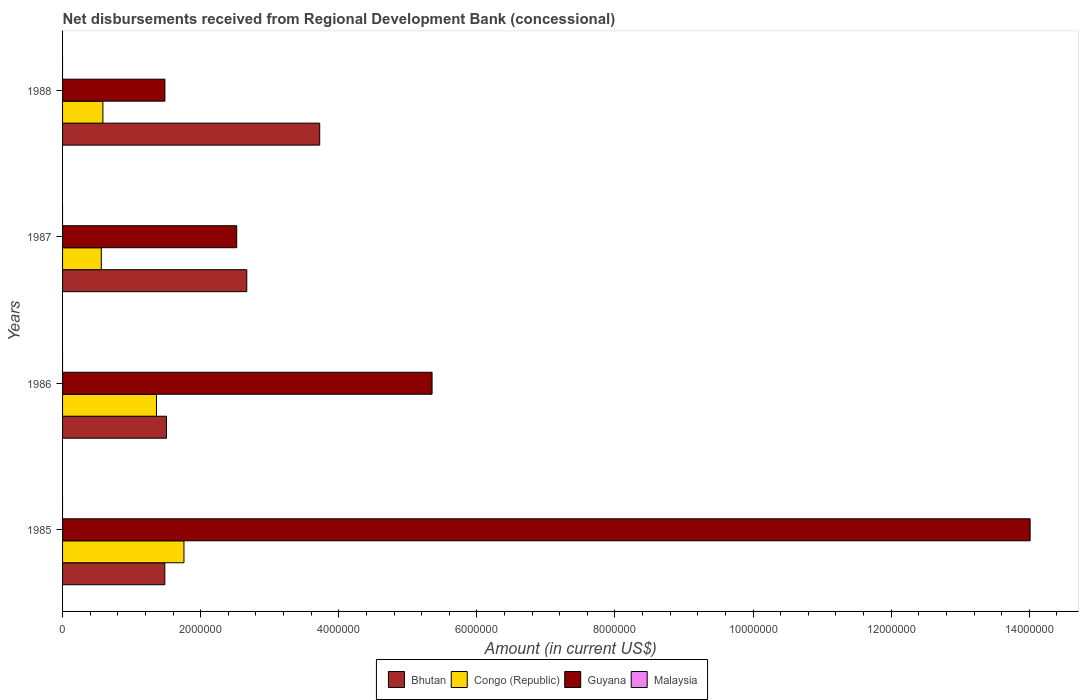How many groups of bars are there?
Offer a terse response. 4. Are the number of bars on each tick of the Y-axis equal?
Provide a succinct answer. Yes. How many bars are there on the 1st tick from the top?
Your answer should be compact. 3. How many bars are there on the 2nd tick from the bottom?
Your response must be concise. 3. Across all years, what is the maximum amount of disbursements received from Regional Development Bank in Guyana?
Offer a very short reply. 1.40e+07. Across all years, what is the minimum amount of disbursements received from Regional Development Bank in Congo (Republic)?
Provide a short and direct response. 5.61e+05. In which year was the amount of disbursements received from Regional Development Bank in Bhutan maximum?
Your response must be concise. 1988. What is the total amount of disbursements received from Regional Development Bank in Guyana in the graph?
Your response must be concise. 2.34e+07. What is the difference between the amount of disbursements received from Regional Development Bank in Congo (Republic) in 1985 and that in 1986?
Your answer should be very brief. 3.98e+05. What is the difference between the amount of disbursements received from Regional Development Bank in Bhutan in 1988 and the amount of disbursements received from Regional Development Bank in Guyana in 1985?
Provide a short and direct response. -1.03e+07. What is the average amount of disbursements received from Regional Development Bank in Guyana per year?
Offer a terse response. 5.84e+06. In the year 1986, what is the difference between the amount of disbursements received from Regional Development Bank in Congo (Republic) and amount of disbursements received from Regional Development Bank in Bhutan?
Offer a terse response. -1.45e+05. What is the ratio of the amount of disbursements received from Regional Development Bank in Bhutan in 1985 to that in 1986?
Provide a short and direct response. 0.98. Is the amount of disbursements received from Regional Development Bank in Guyana in 1985 less than that in 1987?
Provide a short and direct response. No. What is the difference between the highest and the second highest amount of disbursements received from Regional Development Bank in Guyana?
Keep it short and to the point. 8.66e+06. What is the difference between the highest and the lowest amount of disbursements received from Regional Development Bank in Bhutan?
Ensure brevity in your answer.  2.24e+06. Is the sum of the amount of disbursements received from Regional Development Bank in Guyana in 1985 and 1987 greater than the maximum amount of disbursements received from Regional Development Bank in Bhutan across all years?
Provide a short and direct response. Yes. Is it the case that in every year, the sum of the amount of disbursements received from Regional Development Bank in Malaysia and amount of disbursements received from Regional Development Bank in Bhutan is greater than the sum of amount of disbursements received from Regional Development Bank in Guyana and amount of disbursements received from Regional Development Bank in Congo (Republic)?
Your answer should be compact. No. How many bars are there?
Offer a terse response. 12. What is the difference between two consecutive major ticks on the X-axis?
Your answer should be compact. 2.00e+06. Does the graph contain grids?
Make the answer very short. No. Where does the legend appear in the graph?
Give a very brief answer. Bottom center. How many legend labels are there?
Your answer should be very brief. 4. What is the title of the graph?
Your response must be concise. Net disbursements received from Regional Development Bank (concessional). What is the label or title of the Y-axis?
Make the answer very short. Years. What is the Amount (in current US$) in Bhutan in 1985?
Provide a succinct answer. 1.48e+06. What is the Amount (in current US$) in Congo (Republic) in 1985?
Give a very brief answer. 1.76e+06. What is the Amount (in current US$) in Guyana in 1985?
Your answer should be compact. 1.40e+07. What is the Amount (in current US$) in Bhutan in 1986?
Offer a terse response. 1.50e+06. What is the Amount (in current US$) in Congo (Republic) in 1986?
Ensure brevity in your answer.  1.36e+06. What is the Amount (in current US$) in Guyana in 1986?
Make the answer very short. 5.35e+06. What is the Amount (in current US$) in Bhutan in 1987?
Provide a succinct answer. 2.67e+06. What is the Amount (in current US$) in Congo (Republic) in 1987?
Your answer should be very brief. 5.61e+05. What is the Amount (in current US$) in Guyana in 1987?
Provide a short and direct response. 2.52e+06. What is the Amount (in current US$) in Malaysia in 1987?
Provide a short and direct response. 0. What is the Amount (in current US$) of Bhutan in 1988?
Your answer should be very brief. 3.72e+06. What is the Amount (in current US$) of Congo (Republic) in 1988?
Provide a succinct answer. 5.84e+05. What is the Amount (in current US$) in Guyana in 1988?
Provide a short and direct response. 1.48e+06. What is the Amount (in current US$) of Malaysia in 1988?
Offer a terse response. 0. Across all years, what is the maximum Amount (in current US$) in Bhutan?
Provide a short and direct response. 3.72e+06. Across all years, what is the maximum Amount (in current US$) of Congo (Republic)?
Your answer should be very brief. 1.76e+06. Across all years, what is the maximum Amount (in current US$) in Guyana?
Provide a succinct answer. 1.40e+07. Across all years, what is the minimum Amount (in current US$) of Bhutan?
Make the answer very short. 1.48e+06. Across all years, what is the minimum Amount (in current US$) in Congo (Republic)?
Ensure brevity in your answer.  5.61e+05. Across all years, what is the minimum Amount (in current US$) of Guyana?
Offer a terse response. 1.48e+06. What is the total Amount (in current US$) in Bhutan in the graph?
Offer a very short reply. 9.38e+06. What is the total Amount (in current US$) in Congo (Republic) in the graph?
Your answer should be very brief. 4.26e+06. What is the total Amount (in current US$) in Guyana in the graph?
Your response must be concise. 2.34e+07. What is the total Amount (in current US$) of Malaysia in the graph?
Keep it short and to the point. 0. What is the difference between the Amount (in current US$) of Bhutan in 1985 and that in 1986?
Your answer should be very brief. -2.40e+04. What is the difference between the Amount (in current US$) of Congo (Republic) in 1985 and that in 1986?
Ensure brevity in your answer.  3.98e+05. What is the difference between the Amount (in current US$) of Guyana in 1985 and that in 1986?
Provide a short and direct response. 8.66e+06. What is the difference between the Amount (in current US$) of Bhutan in 1985 and that in 1987?
Keep it short and to the point. -1.19e+06. What is the difference between the Amount (in current US$) of Congo (Republic) in 1985 and that in 1987?
Offer a very short reply. 1.20e+06. What is the difference between the Amount (in current US$) in Guyana in 1985 and that in 1987?
Your response must be concise. 1.15e+07. What is the difference between the Amount (in current US$) of Bhutan in 1985 and that in 1988?
Offer a very short reply. -2.24e+06. What is the difference between the Amount (in current US$) in Congo (Republic) in 1985 and that in 1988?
Keep it short and to the point. 1.17e+06. What is the difference between the Amount (in current US$) in Guyana in 1985 and that in 1988?
Your answer should be very brief. 1.25e+07. What is the difference between the Amount (in current US$) of Bhutan in 1986 and that in 1987?
Your response must be concise. -1.16e+06. What is the difference between the Amount (in current US$) of Congo (Republic) in 1986 and that in 1987?
Offer a very short reply. 7.99e+05. What is the difference between the Amount (in current US$) of Guyana in 1986 and that in 1987?
Offer a terse response. 2.83e+06. What is the difference between the Amount (in current US$) in Bhutan in 1986 and that in 1988?
Your answer should be compact. -2.22e+06. What is the difference between the Amount (in current US$) in Congo (Republic) in 1986 and that in 1988?
Provide a succinct answer. 7.76e+05. What is the difference between the Amount (in current US$) in Guyana in 1986 and that in 1988?
Keep it short and to the point. 3.87e+06. What is the difference between the Amount (in current US$) in Bhutan in 1987 and that in 1988?
Your answer should be compact. -1.06e+06. What is the difference between the Amount (in current US$) in Congo (Republic) in 1987 and that in 1988?
Your answer should be very brief. -2.30e+04. What is the difference between the Amount (in current US$) of Guyana in 1987 and that in 1988?
Keep it short and to the point. 1.04e+06. What is the difference between the Amount (in current US$) of Bhutan in 1985 and the Amount (in current US$) of Congo (Republic) in 1986?
Provide a succinct answer. 1.21e+05. What is the difference between the Amount (in current US$) of Bhutan in 1985 and the Amount (in current US$) of Guyana in 1986?
Give a very brief answer. -3.87e+06. What is the difference between the Amount (in current US$) of Congo (Republic) in 1985 and the Amount (in current US$) of Guyana in 1986?
Your response must be concise. -3.59e+06. What is the difference between the Amount (in current US$) in Bhutan in 1985 and the Amount (in current US$) in Congo (Republic) in 1987?
Make the answer very short. 9.20e+05. What is the difference between the Amount (in current US$) in Bhutan in 1985 and the Amount (in current US$) in Guyana in 1987?
Give a very brief answer. -1.04e+06. What is the difference between the Amount (in current US$) of Congo (Republic) in 1985 and the Amount (in current US$) of Guyana in 1987?
Provide a short and direct response. -7.64e+05. What is the difference between the Amount (in current US$) of Bhutan in 1985 and the Amount (in current US$) of Congo (Republic) in 1988?
Make the answer very short. 8.97e+05. What is the difference between the Amount (in current US$) in Bhutan in 1985 and the Amount (in current US$) in Guyana in 1988?
Offer a terse response. -1000. What is the difference between the Amount (in current US$) in Congo (Republic) in 1985 and the Amount (in current US$) in Guyana in 1988?
Give a very brief answer. 2.76e+05. What is the difference between the Amount (in current US$) of Bhutan in 1986 and the Amount (in current US$) of Congo (Republic) in 1987?
Your answer should be very brief. 9.44e+05. What is the difference between the Amount (in current US$) of Bhutan in 1986 and the Amount (in current US$) of Guyana in 1987?
Provide a succinct answer. -1.02e+06. What is the difference between the Amount (in current US$) in Congo (Republic) in 1986 and the Amount (in current US$) in Guyana in 1987?
Make the answer very short. -1.16e+06. What is the difference between the Amount (in current US$) in Bhutan in 1986 and the Amount (in current US$) in Congo (Republic) in 1988?
Your answer should be compact. 9.21e+05. What is the difference between the Amount (in current US$) in Bhutan in 1986 and the Amount (in current US$) in Guyana in 1988?
Provide a succinct answer. 2.30e+04. What is the difference between the Amount (in current US$) in Congo (Republic) in 1986 and the Amount (in current US$) in Guyana in 1988?
Provide a succinct answer. -1.22e+05. What is the difference between the Amount (in current US$) of Bhutan in 1987 and the Amount (in current US$) of Congo (Republic) in 1988?
Your answer should be very brief. 2.08e+06. What is the difference between the Amount (in current US$) in Bhutan in 1987 and the Amount (in current US$) in Guyana in 1988?
Offer a terse response. 1.19e+06. What is the difference between the Amount (in current US$) of Congo (Republic) in 1987 and the Amount (in current US$) of Guyana in 1988?
Ensure brevity in your answer.  -9.21e+05. What is the average Amount (in current US$) of Bhutan per year?
Ensure brevity in your answer.  2.34e+06. What is the average Amount (in current US$) in Congo (Republic) per year?
Make the answer very short. 1.07e+06. What is the average Amount (in current US$) in Guyana per year?
Give a very brief answer. 5.84e+06. What is the average Amount (in current US$) in Malaysia per year?
Keep it short and to the point. 0. In the year 1985, what is the difference between the Amount (in current US$) in Bhutan and Amount (in current US$) in Congo (Republic)?
Provide a short and direct response. -2.77e+05. In the year 1985, what is the difference between the Amount (in current US$) in Bhutan and Amount (in current US$) in Guyana?
Ensure brevity in your answer.  -1.25e+07. In the year 1985, what is the difference between the Amount (in current US$) of Congo (Republic) and Amount (in current US$) of Guyana?
Your response must be concise. -1.23e+07. In the year 1986, what is the difference between the Amount (in current US$) of Bhutan and Amount (in current US$) of Congo (Republic)?
Provide a succinct answer. 1.45e+05. In the year 1986, what is the difference between the Amount (in current US$) in Bhutan and Amount (in current US$) in Guyana?
Provide a succinct answer. -3.85e+06. In the year 1986, what is the difference between the Amount (in current US$) in Congo (Republic) and Amount (in current US$) in Guyana?
Give a very brief answer. -3.99e+06. In the year 1987, what is the difference between the Amount (in current US$) of Bhutan and Amount (in current US$) of Congo (Republic)?
Your answer should be very brief. 2.11e+06. In the year 1987, what is the difference between the Amount (in current US$) of Bhutan and Amount (in current US$) of Guyana?
Your answer should be compact. 1.46e+05. In the year 1987, what is the difference between the Amount (in current US$) of Congo (Republic) and Amount (in current US$) of Guyana?
Your answer should be very brief. -1.96e+06. In the year 1988, what is the difference between the Amount (in current US$) in Bhutan and Amount (in current US$) in Congo (Republic)?
Your answer should be very brief. 3.14e+06. In the year 1988, what is the difference between the Amount (in current US$) of Bhutan and Amount (in current US$) of Guyana?
Ensure brevity in your answer.  2.24e+06. In the year 1988, what is the difference between the Amount (in current US$) in Congo (Republic) and Amount (in current US$) in Guyana?
Give a very brief answer. -8.98e+05. What is the ratio of the Amount (in current US$) in Bhutan in 1985 to that in 1986?
Give a very brief answer. 0.98. What is the ratio of the Amount (in current US$) in Congo (Republic) in 1985 to that in 1986?
Give a very brief answer. 1.29. What is the ratio of the Amount (in current US$) in Guyana in 1985 to that in 1986?
Ensure brevity in your answer.  2.62. What is the ratio of the Amount (in current US$) in Bhutan in 1985 to that in 1987?
Your answer should be very brief. 0.56. What is the ratio of the Amount (in current US$) in Congo (Republic) in 1985 to that in 1987?
Offer a terse response. 3.13. What is the ratio of the Amount (in current US$) of Guyana in 1985 to that in 1987?
Give a very brief answer. 5.56. What is the ratio of the Amount (in current US$) in Bhutan in 1985 to that in 1988?
Your answer should be compact. 0.4. What is the ratio of the Amount (in current US$) in Congo (Republic) in 1985 to that in 1988?
Your response must be concise. 3.01. What is the ratio of the Amount (in current US$) in Guyana in 1985 to that in 1988?
Your answer should be very brief. 9.45. What is the ratio of the Amount (in current US$) of Bhutan in 1986 to that in 1987?
Keep it short and to the point. 0.56. What is the ratio of the Amount (in current US$) of Congo (Republic) in 1986 to that in 1987?
Provide a short and direct response. 2.42. What is the ratio of the Amount (in current US$) of Guyana in 1986 to that in 1987?
Offer a very short reply. 2.12. What is the ratio of the Amount (in current US$) of Bhutan in 1986 to that in 1988?
Offer a very short reply. 0.4. What is the ratio of the Amount (in current US$) of Congo (Republic) in 1986 to that in 1988?
Keep it short and to the point. 2.33. What is the ratio of the Amount (in current US$) in Guyana in 1986 to that in 1988?
Provide a succinct answer. 3.61. What is the ratio of the Amount (in current US$) in Bhutan in 1987 to that in 1988?
Your response must be concise. 0.72. What is the ratio of the Amount (in current US$) in Congo (Republic) in 1987 to that in 1988?
Give a very brief answer. 0.96. What is the ratio of the Amount (in current US$) in Guyana in 1987 to that in 1988?
Keep it short and to the point. 1.7. What is the difference between the highest and the second highest Amount (in current US$) of Bhutan?
Provide a short and direct response. 1.06e+06. What is the difference between the highest and the second highest Amount (in current US$) of Congo (Republic)?
Your answer should be compact. 3.98e+05. What is the difference between the highest and the second highest Amount (in current US$) in Guyana?
Give a very brief answer. 8.66e+06. What is the difference between the highest and the lowest Amount (in current US$) in Bhutan?
Your response must be concise. 2.24e+06. What is the difference between the highest and the lowest Amount (in current US$) of Congo (Republic)?
Ensure brevity in your answer.  1.20e+06. What is the difference between the highest and the lowest Amount (in current US$) in Guyana?
Provide a succinct answer. 1.25e+07. 